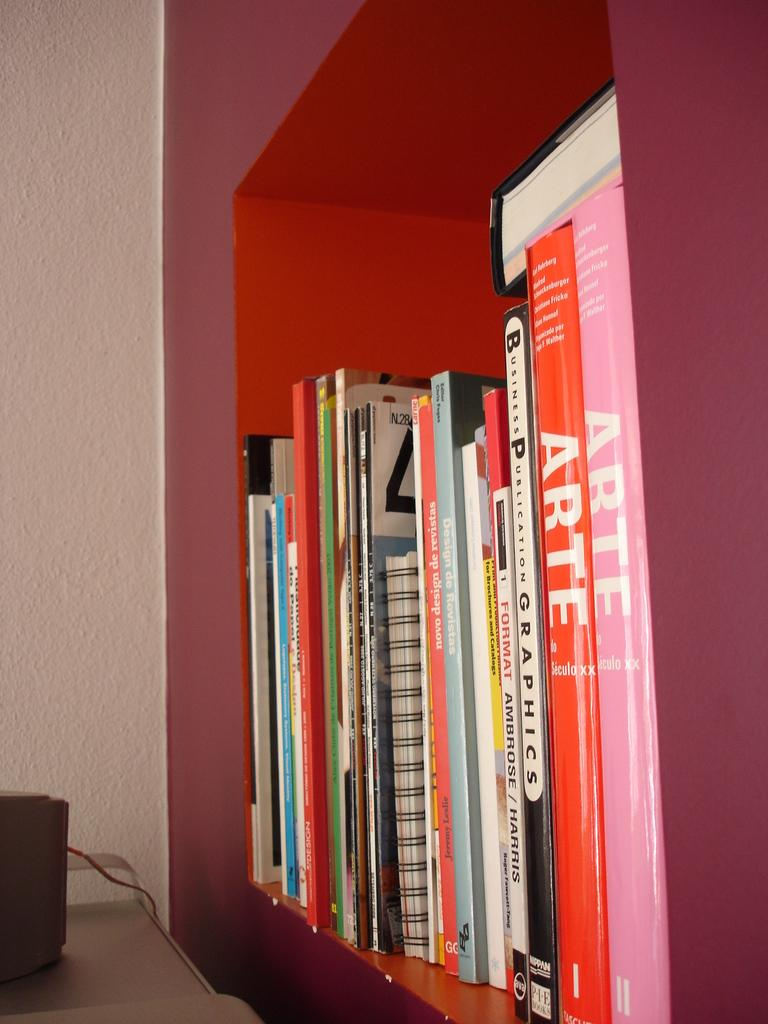Provide a one-sentence caption for the provided image. Two books called ARTE sit on a shelf with many other books. 